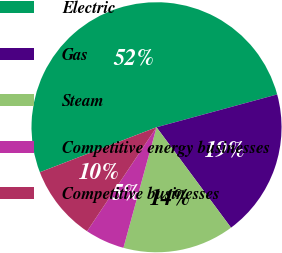Convert chart. <chart><loc_0><loc_0><loc_500><loc_500><pie_chart><fcel>Electric<fcel>Gas<fcel>Steam<fcel>Competitive energy businesses<fcel>Competitive businesses<nl><fcel>51.63%<fcel>19.07%<fcel>14.42%<fcel>5.11%<fcel>9.77%<nl></chart> 